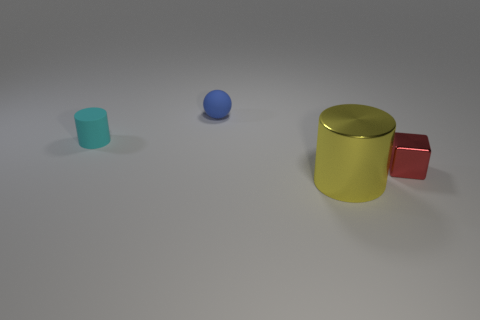Add 2 tiny red cubes. How many objects exist? 6 Subtract all balls. How many objects are left? 3 Add 4 big metallic cylinders. How many big metallic cylinders are left? 5 Add 1 large shiny things. How many large shiny things exist? 2 Subtract 0 purple cylinders. How many objects are left? 4 Subtract all small blue metallic cubes. Subtract all red cubes. How many objects are left? 3 